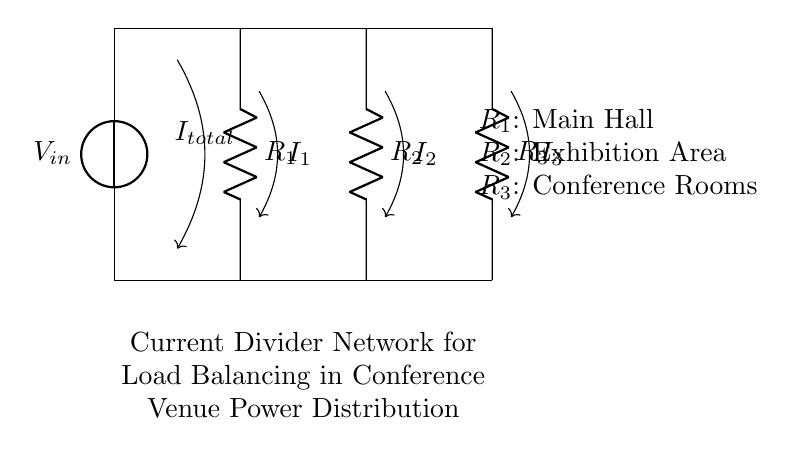What is the total current entering the circuit? The total current entering the circuit is represented as I total, which flows from the voltage source into the circuit.
Answer: I total What are the resistances in the circuit? The circuit consists of three resistances: R1, R2, and R3, which represent the different areas of the conference venue.
Answer: R1, R2, R3 Which area is represented by R2? R2 represents the Exhibition Area, labeled in the diagram as such.
Answer: Exhibition Area How does the current split among the resistors? The current splits inversely proportional to the resistances, meaning that the resistor with the smallest resistance will have the highest current flowing through it.
Answer: Inversely proportional What is the relationship between the resistors in the current divider? The resistors are in parallel in a current divider configuration, which allows the input current to be divided among the parallel branches according to their resistances.
Answer: Parallel Which resistor would carry the least current? The resistor with the highest resistance would carry the least current, which is based on the current divider rule.
Answer: R1 (if R1 > R2 and R3) 